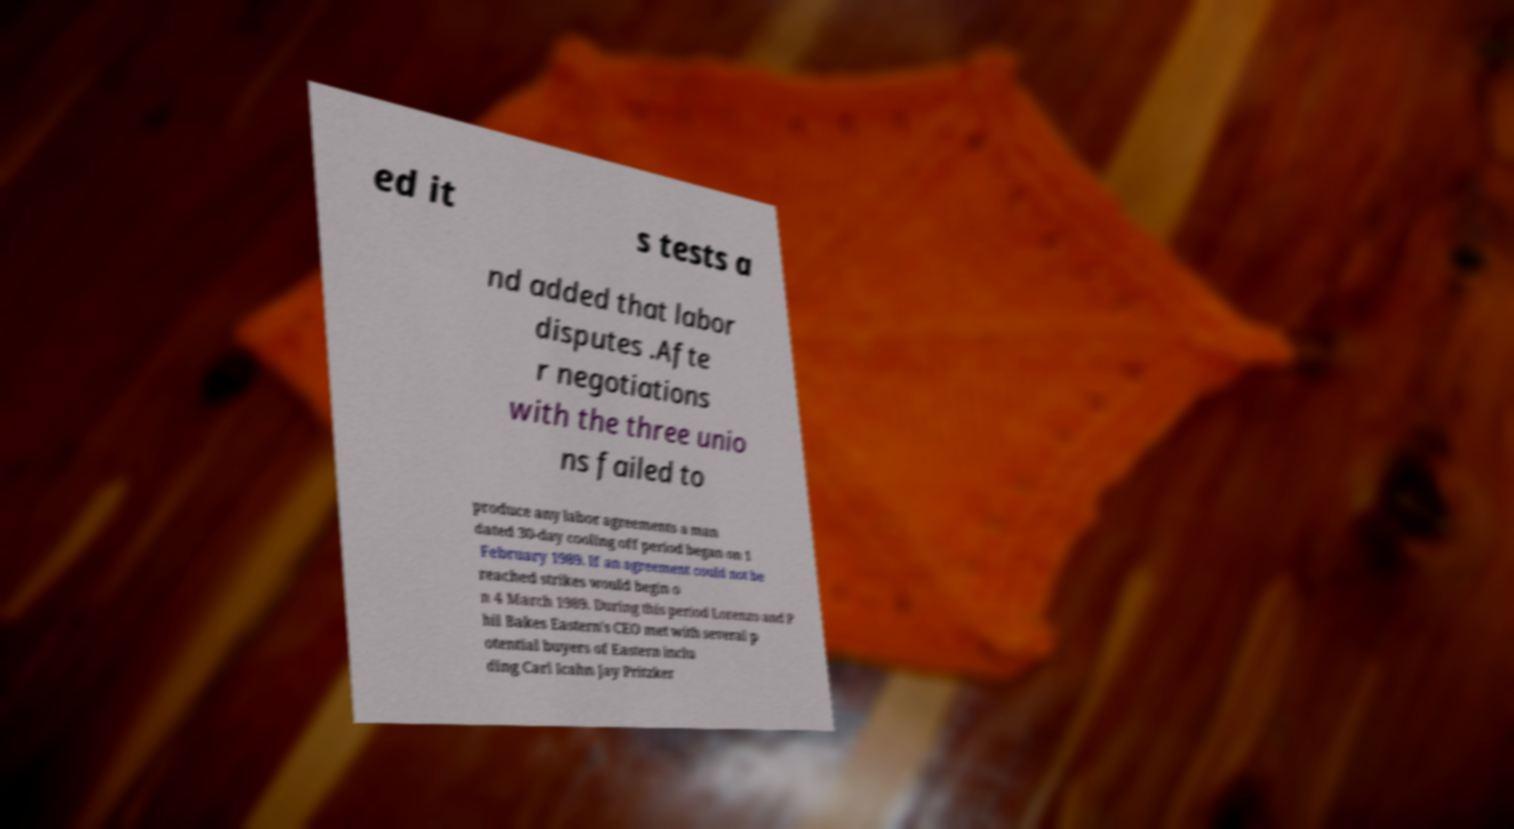Please identify and transcribe the text found in this image. ed it s tests a nd added that labor disputes .Afte r negotiations with the three unio ns failed to produce any labor agreements a man dated 30-day cooling off period began on 1 February 1989. If an agreement could not be reached strikes would begin o n 4 March 1989. During this period Lorenzo and P hil Bakes Eastern's CEO met with several p otential buyers of Eastern inclu ding Carl Icahn Jay Pritzker 